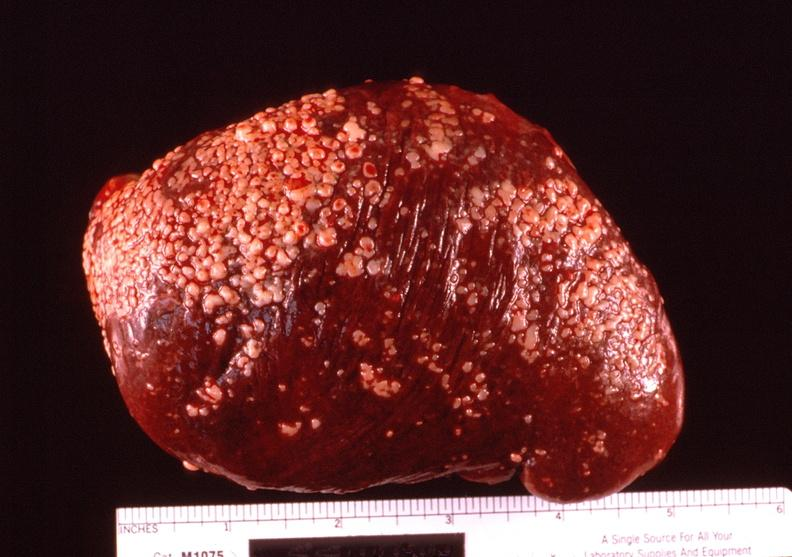what is present?
Answer the question using a single word or phrase. Hematologic 